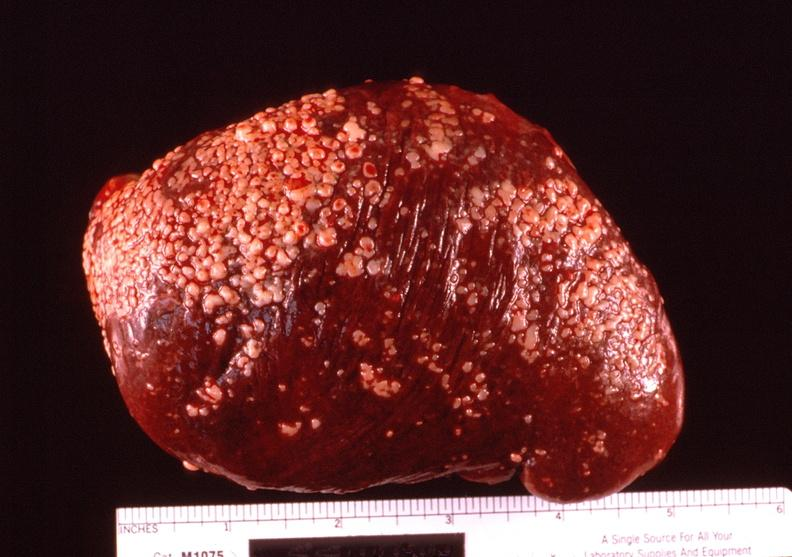what is present?
Answer the question using a single word or phrase. Hematologic 